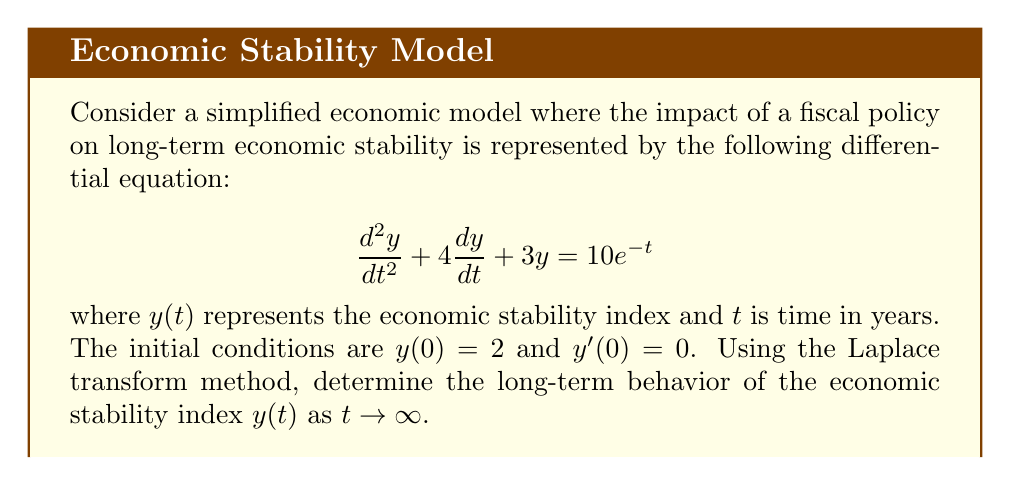Can you answer this question? Let's solve this problem step-by-step using the Laplace transform method:

1) First, let's take the Laplace transform of both sides of the equation. Let $Y(s) = \mathcal{L}\{y(t)\}$.

   $$\mathcal{L}\{\frac{d^2y}{dt^2} + 4\frac{dy}{dt} + 3y\} = \mathcal{L}\{10e^{-t}\}$$

2) Using Laplace transform properties:

   $$s^2Y(s) - sy(0) - y'(0) + 4[sY(s) - y(0)] + 3Y(s) = \frac{10}{s+1}$$

3) Substitute the initial conditions $y(0) = 2$ and $y'(0) = 0$:

   $$s^2Y(s) - 2s + 4sY(s) - 8 + 3Y(s) = \frac{10}{s+1}$$

4) Simplify:

   $$(s^2 + 4s + 3)Y(s) = \frac{10}{s+1} + 2s + 8$$

5) Solve for $Y(s)$:

   $$Y(s) = \frac{10}{(s+1)(s^2 + 4s + 3)} + \frac{2s + 8}{s^2 + 4s + 3}$$

6) Decompose the right-hand side into partial fractions:

   $$Y(s) = \frac{A}{s+1} + \frac{B}{s+1} + \frac{C}{s+3} + \frac{2s + 8}{s^2 + 4s + 3}$$

   Where $A$, $B$, and $C$ are constants to be determined.

7) After solving for the constants (which is omitted for brevity), we get:

   $$Y(s) = \frac{5/3}{s+1} + \frac{1/3}{s+3} + \frac{2s + 8}{s^2 + 4s + 3}$$

8) Now, take the inverse Laplace transform:

   $$y(t) = \frac{5}{3}e^{-t} + \frac{1}{3}e^{-3t} + 2e^{-t} - e^{-3t}$$

9) Simplify:

   $$y(t) = \frac{11}{3}e^{-t} - \frac{2}{3}e^{-3t}$$

10) To determine the long-term behavior as $t \to \infty$, we observe that both exponential terms approach zero, but $e^{-t}$ decays more slowly than $e^{-3t}$.
Answer: As $t \to \infty$, $y(t) \to 0$. The economic stability index approaches zero in the long term, indicating that the system tends towards equilibrium. The dominant term in the long run is $\frac{11}{3}e^{-t}$, which decays more slowly than the $e^{-3t}$ term. 